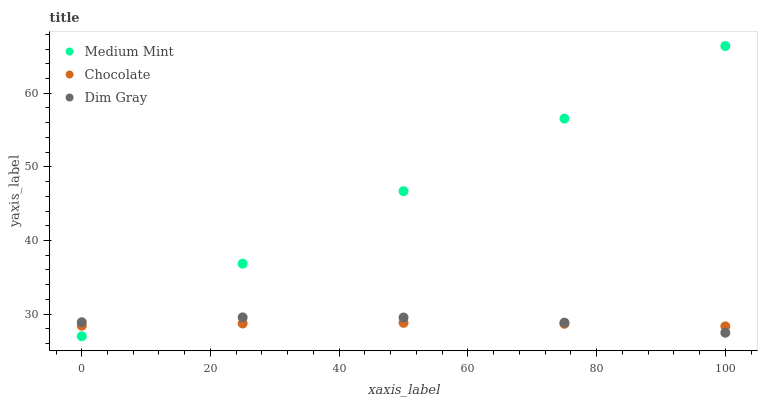Does Chocolate have the minimum area under the curve?
Answer yes or no. Yes. Does Medium Mint have the maximum area under the curve?
Answer yes or no. Yes. Does Dim Gray have the minimum area under the curve?
Answer yes or no. No. Does Dim Gray have the maximum area under the curve?
Answer yes or no. No. Is Medium Mint the smoothest?
Answer yes or no. Yes. Is Dim Gray the roughest?
Answer yes or no. Yes. Is Chocolate the smoothest?
Answer yes or no. No. Is Chocolate the roughest?
Answer yes or no. No. Does Medium Mint have the lowest value?
Answer yes or no. Yes. Does Dim Gray have the lowest value?
Answer yes or no. No. Does Medium Mint have the highest value?
Answer yes or no. Yes. Does Dim Gray have the highest value?
Answer yes or no. No. Does Dim Gray intersect Chocolate?
Answer yes or no. Yes. Is Dim Gray less than Chocolate?
Answer yes or no. No. Is Dim Gray greater than Chocolate?
Answer yes or no. No. 